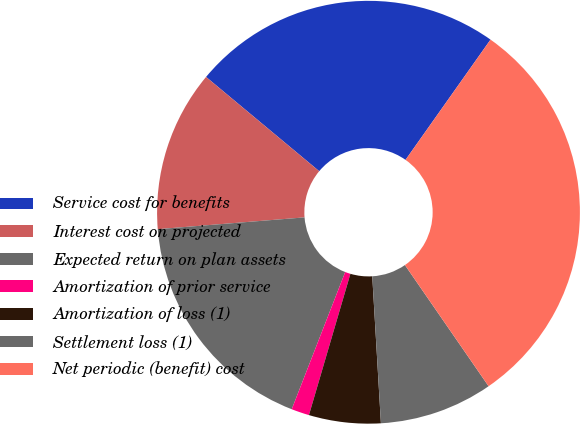<chart> <loc_0><loc_0><loc_500><loc_500><pie_chart><fcel>Service cost for benefits<fcel>Interest cost on projected<fcel>Expected return on plan assets<fcel>Amortization of prior service<fcel>Amortization of loss (1)<fcel>Settlement loss (1)<fcel>Net periodic (benefit) cost<nl><fcel>23.74%<fcel>12.33%<fcel>17.81%<fcel>1.37%<fcel>5.48%<fcel>8.68%<fcel>30.59%<nl></chart> 